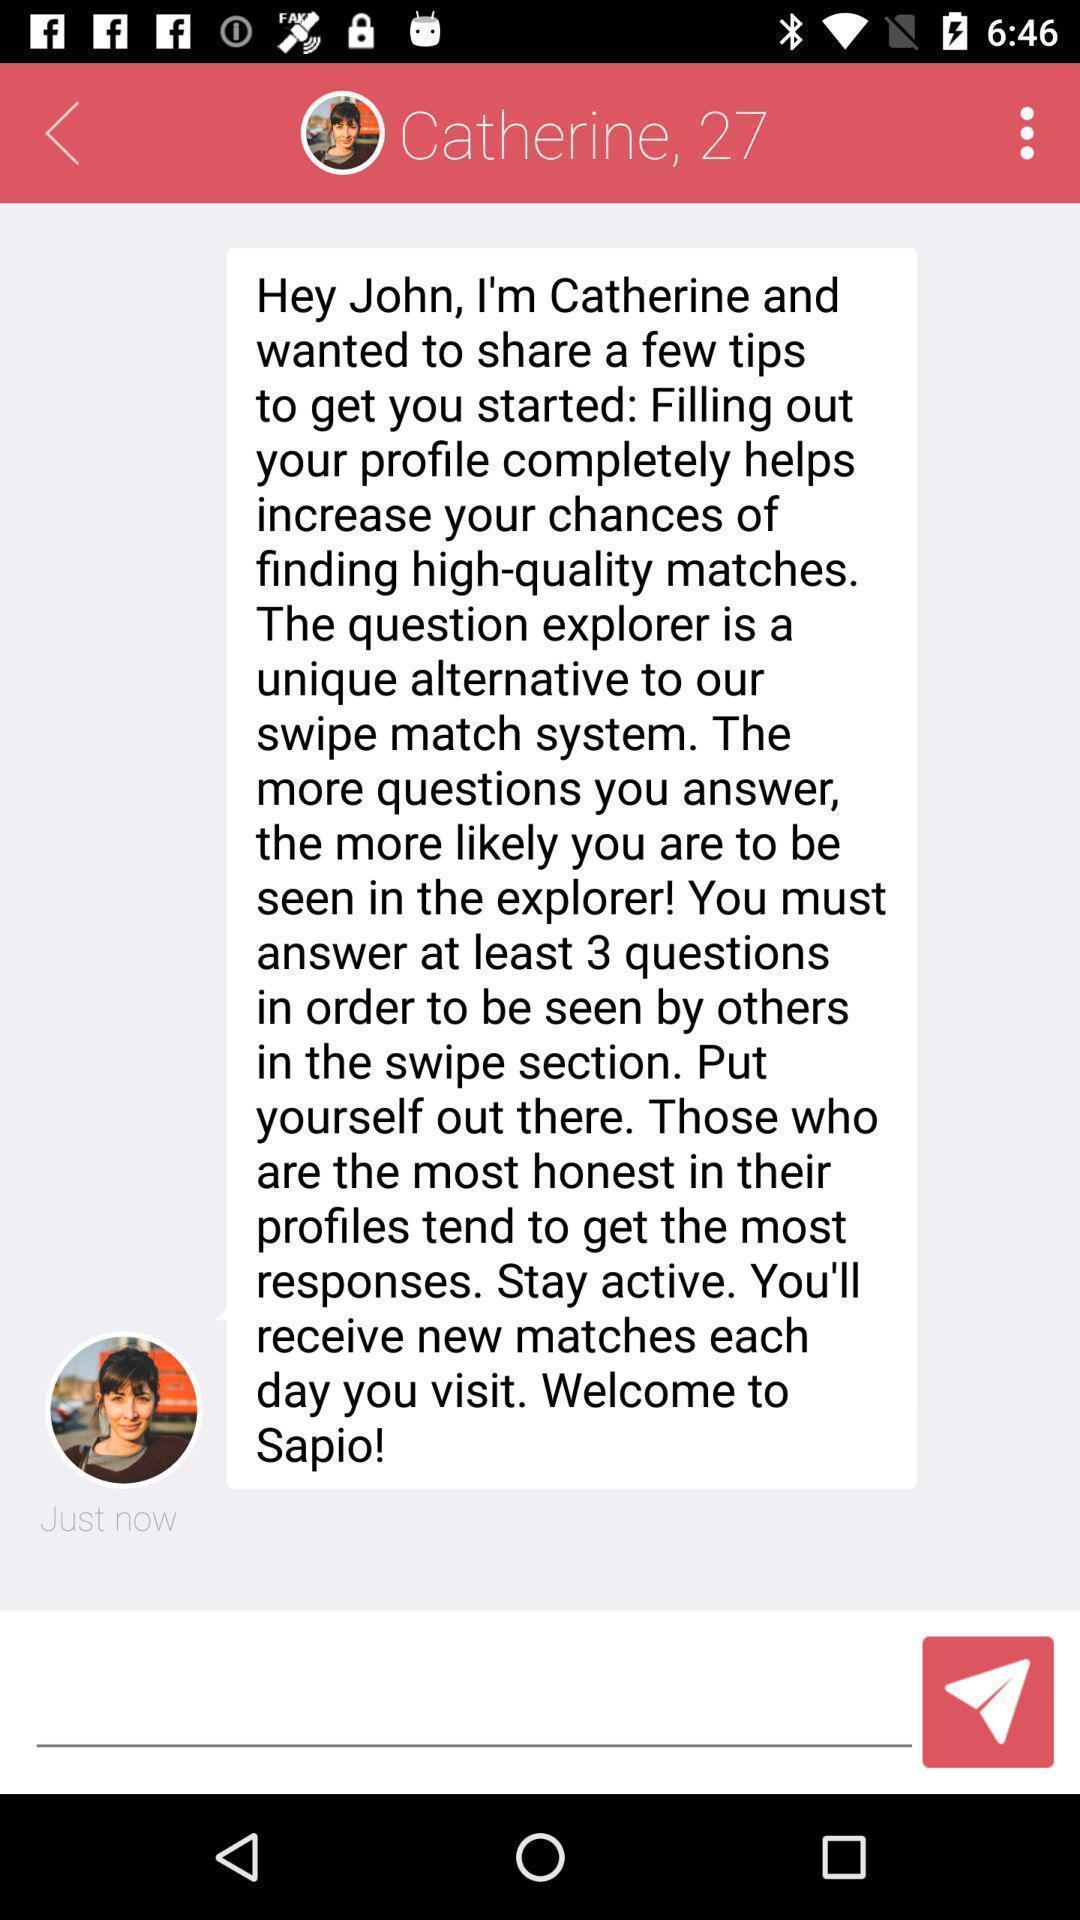What can you discern from this picture? Textarea is available in the chat box. 